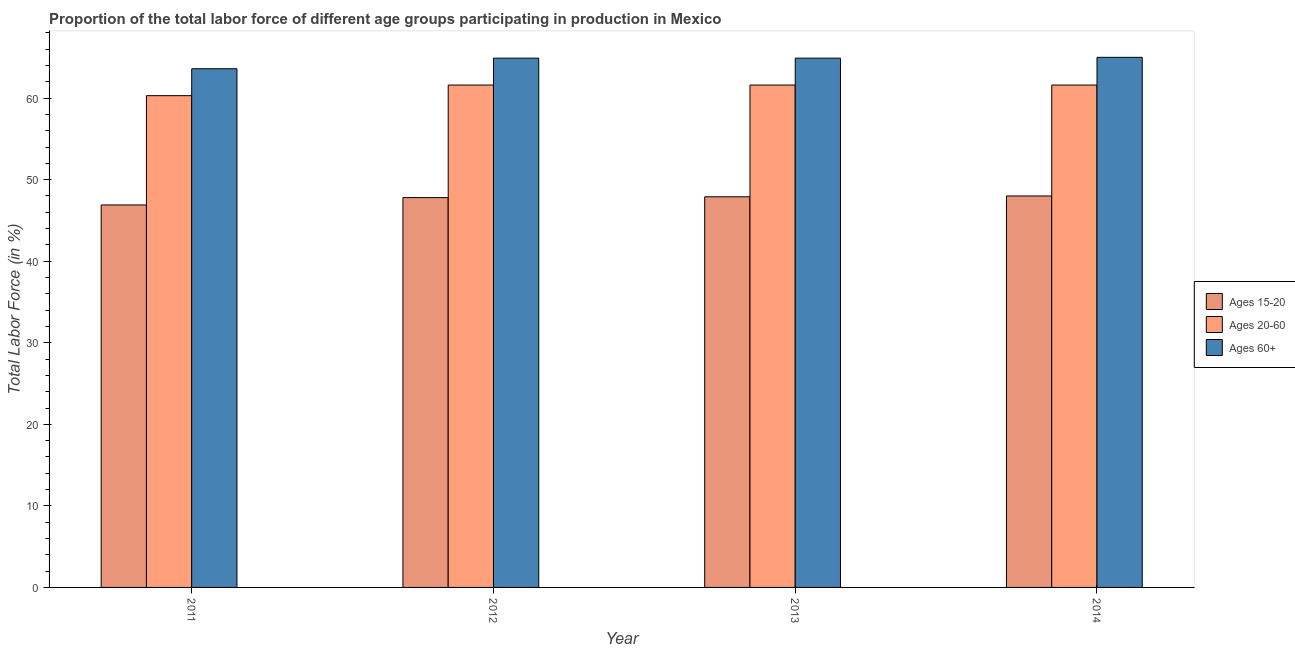Are the number of bars per tick equal to the number of legend labels?
Ensure brevity in your answer.  Yes. How many bars are there on the 4th tick from the left?
Make the answer very short. 3. How many bars are there on the 3rd tick from the right?
Ensure brevity in your answer.  3. What is the label of the 1st group of bars from the left?
Keep it short and to the point. 2011. In how many cases, is the number of bars for a given year not equal to the number of legend labels?
Provide a short and direct response. 0. What is the percentage of labor force within the age group 15-20 in 2011?
Provide a short and direct response. 46.9. Across all years, what is the maximum percentage of labor force above age 60?
Provide a short and direct response. 65. Across all years, what is the minimum percentage of labor force within the age group 20-60?
Your response must be concise. 60.3. What is the total percentage of labor force within the age group 15-20 in the graph?
Provide a short and direct response. 190.6. What is the difference between the percentage of labor force within the age group 15-20 in 2011 and that in 2012?
Your response must be concise. -0.9. What is the difference between the percentage of labor force within the age group 15-20 in 2013 and the percentage of labor force above age 60 in 2012?
Your answer should be compact. 0.1. What is the average percentage of labor force above age 60 per year?
Make the answer very short. 64.6. What is the ratio of the percentage of labor force within the age group 15-20 in 2013 to that in 2014?
Keep it short and to the point. 1. Is the percentage of labor force within the age group 15-20 in 2012 less than that in 2014?
Provide a succinct answer. Yes. What is the difference between the highest and the second highest percentage of labor force above age 60?
Offer a terse response. 0.1. What is the difference between the highest and the lowest percentage of labor force within the age group 20-60?
Keep it short and to the point. 1.3. In how many years, is the percentage of labor force within the age group 15-20 greater than the average percentage of labor force within the age group 15-20 taken over all years?
Provide a succinct answer. 3. What does the 2nd bar from the left in 2013 represents?
Give a very brief answer. Ages 20-60. What does the 2nd bar from the right in 2011 represents?
Ensure brevity in your answer.  Ages 20-60. Is it the case that in every year, the sum of the percentage of labor force within the age group 15-20 and percentage of labor force within the age group 20-60 is greater than the percentage of labor force above age 60?
Provide a succinct answer. Yes. How many bars are there?
Give a very brief answer. 12. What is the difference between two consecutive major ticks on the Y-axis?
Provide a short and direct response. 10. Are the values on the major ticks of Y-axis written in scientific E-notation?
Offer a terse response. No. What is the title of the graph?
Offer a very short reply. Proportion of the total labor force of different age groups participating in production in Mexico. Does "Infant(male)" appear as one of the legend labels in the graph?
Your answer should be compact. No. What is the label or title of the X-axis?
Keep it short and to the point. Year. What is the Total Labor Force (in %) of Ages 15-20 in 2011?
Offer a very short reply. 46.9. What is the Total Labor Force (in %) of Ages 20-60 in 2011?
Offer a very short reply. 60.3. What is the Total Labor Force (in %) of Ages 60+ in 2011?
Provide a succinct answer. 63.6. What is the Total Labor Force (in %) of Ages 15-20 in 2012?
Your answer should be compact. 47.8. What is the Total Labor Force (in %) of Ages 20-60 in 2012?
Keep it short and to the point. 61.6. What is the Total Labor Force (in %) in Ages 60+ in 2012?
Your answer should be very brief. 64.9. What is the Total Labor Force (in %) in Ages 15-20 in 2013?
Offer a very short reply. 47.9. What is the Total Labor Force (in %) in Ages 20-60 in 2013?
Provide a succinct answer. 61.6. What is the Total Labor Force (in %) in Ages 60+ in 2013?
Offer a very short reply. 64.9. What is the Total Labor Force (in %) in Ages 15-20 in 2014?
Give a very brief answer. 48. What is the Total Labor Force (in %) of Ages 20-60 in 2014?
Your answer should be compact. 61.6. Across all years, what is the maximum Total Labor Force (in %) of Ages 15-20?
Make the answer very short. 48. Across all years, what is the maximum Total Labor Force (in %) of Ages 20-60?
Provide a short and direct response. 61.6. Across all years, what is the minimum Total Labor Force (in %) of Ages 15-20?
Offer a very short reply. 46.9. Across all years, what is the minimum Total Labor Force (in %) of Ages 20-60?
Offer a terse response. 60.3. Across all years, what is the minimum Total Labor Force (in %) of Ages 60+?
Provide a succinct answer. 63.6. What is the total Total Labor Force (in %) of Ages 15-20 in the graph?
Make the answer very short. 190.6. What is the total Total Labor Force (in %) of Ages 20-60 in the graph?
Offer a very short reply. 245.1. What is the total Total Labor Force (in %) of Ages 60+ in the graph?
Provide a short and direct response. 258.4. What is the difference between the Total Labor Force (in %) in Ages 15-20 in 2011 and that in 2013?
Offer a very short reply. -1. What is the difference between the Total Labor Force (in %) of Ages 15-20 in 2011 and that in 2014?
Keep it short and to the point. -1.1. What is the difference between the Total Labor Force (in %) in Ages 60+ in 2011 and that in 2014?
Give a very brief answer. -1.4. What is the difference between the Total Labor Force (in %) of Ages 15-20 in 2012 and that in 2013?
Ensure brevity in your answer.  -0.1. What is the difference between the Total Labor Force (in %) in Ages 60+ in 2012 and that in 2013?
Provide a short and direct response. 0. What is the difference between the Total Labor Force (in %) of Ages 15-20 in 2012 and that in 2014?
Keep it short and to the point. -0.2. What is the difference between the Total Labor Force (in %) of Ages 60+ in 2013 and that in 2014?
Your answer should be very brief. -0.1. What is the difference between the Total Labor Force (in %) in Ages 15-20 in 2011 and the Total Labor Force (in %) in Ages 20-60 in 2012?
Provide a short and direct response. -14.7. What is the difference between the Total Labor Force (in %) of Ages 20-60 in 2011 and the Total Labor Force (in %) of Ages 60+ in 2012?
Provide a short and direct response. -4.6. What is the difference between the Total Labor Force (in %) in Ages 15-20 in 2011 and the Total Labor Force (in %) in Ages 20-60 in 2013?
Keep it short and to the point. -14.7. What is the difference between the Total Labor Force (in %) in Ages 20-60 in 2011 and the Total Labor Force (in %) in Ages 60+ in 2013?
Your response must be concise. -4.6. What is the difference between the Total Labor Force (in %) in Ages 15-20 in 2011 and the Total Labor Force (in %) in Ages 20-60 in 2014?
Offer a very short reply. -14.7. What is the difference between the Total Labor Force (in %) of Ages 15-20 in 2011 and the Total Labor Force (in %) of Ages 60+ in 2014?
Provide a succinct answer. -18.1. What is the difference between the Total Labor Force (in %) in Ages 20-60 in 2011 and the Total Labor Force (in %) in Ages 60+ in 2014?
Keep it short and to the point. -4.7. What is the difference between the Total Labor Force (in %) of Ages 15-20 in 2012 and the Total Labor Force (in %) of Ages 60+ in 2013?
Ensure brevity in your answer.  -17.1. What is the difference between the Total Labor Force (in %) in Ages 20-60 in 2012 and the Total Labor Force (in %) in Ages 60+ in 2013?
Offer a terse response. -3.3. What is the difference between the Total Labor Force (in %) in Ages 15-20 in 2012 and the Total Labor Force (in %) in Ages 60+ in 2014?
Your answer should be very brief. -17.2. What is the difference between the Total Labor Force (in %) of Ages 20-60 in 2012 and the Total Labor Force (in %) of Ages 60+ in 2014?
Ensure brevity in your answer.  -3.4. What is the difference between the Total Labor Force (in %) in Ages 15-20 in 2013 and the Total Labor Force (in %) in Ages 20-60 in 2014?
Offer a terse response. -13.7. What is the difference between the Total Labor Force (in %) of Ages 15-20 in 2013 and the Total Labor Force (in %) of Ages 60+ in 2014?
Your response must be concise. -17.1. What is the average Total Labor Force (in %) in Ages 15-20 per year?
Your answer should be very brief. 47.65. What is the average Total Labor Force (in %) of Ages 20-60 per year?
Your answer should be very brief. 61.27. What is the average Total Labor Force (in %) in Ages 60+ per year?
Provide a succinct answer. 64.6. In the year 2011, what is the difference between the Total Labor Force (in %) of Ages 15-20 and Total Labor Force (in %) of Ages 60+?
Your answer should be compact. -16.7. In the year 2012, what is the difference between the Total Labor Force (in %) in Ages 15-20 and Total Labor Force (in %) in Ages 60+?
Your answer should be compact. -17.1. In the year 2013, what is the difference between the Total Labor Force (in %) of Ages 15-20 and Total Labor Force (in %) of Ages 20-60?
Your response must be concise. -13.7. In the year 2013, what is the difference between the Total Labor Force (in %) of Ages 15-20 and Total Labor Force (in %) of Ages 60+?
Keep it short and to the point. -17. In the year 2014, what is the difference between the Total Labor Force (in %) in Ages 15-20 and Total Labor Force (in %) in Ages 20-60?
Your answer should be compact. -13.6. In the year 2014, what is the difference between the Total Labor Force (in %) of Ages 15-20 and Total Labor Force (in %) of Ages 60+?
Provide a succinct answer. -17. In the year 2014, what is the difference between the Total Labor Force (in %) of Ages 20-60 and Total Labor Force (in %) of Ages 60+?
Keep it short and to the point. -3.4. What is the ratio of the Total Labor Force (in %) in Ages 15-20 in 2011 to that in 2012?
Give a very brief answer. 0.98. What is the ratio of the Total Labor Force (in %) in Ages 20-60 in 2011 to that in 2012?
Ensure brevity in your answer.  0.98. What is the ratio of the Total Labor Force (in %) in Ages 15-20 in 2011 to that in 2013?
Provide a short and direct response. 0.98. What is the ratio of the Total Labor Force (in %) in Ages 20-60 in 2011 to that in 2013?
Keep it short and to the point. 0.98. What is the ratio of the Total Labor Force (in %) of Ages 15-20 in 2011 to that in 2014?
Make the answer very short. 0.98. What is the ratio of the Total Labor Force (in %) of Ages 20-60 in 2011 to that in 2014?
Provide a succinct answer. 0.98. What is the ratio of the Total Labor Force (in %) in Ages 60+ in 2011 to that in 2014?
Offer a very short reply. 0.98. What is the ratio of the Total Labor Force (in %) of Ages 15-20 in 2012 to that in 2013?
Give a very brief answer. 1. What is the ratio of the Total Labor Force (in %) in Ages 20-60 in 2012 to that in 2013?
Ensure brevity in your answer.  1. What is the ratio of the Total Labor Force (in %) of Ages 15-20 in 2012 to that in 2014?
Offer a terse response. 1. What is the ratio of the Total Labor Force (in %) of Ages 15-20 in 2013 to that in 2014?
Make the answer very short. 1. What is the ratio of the Total Labor Force (in %) of Ages 60+ in 2013 to that in 2014?
Offer a very short reply. 1. What is the difference between the highest and the second highest Total Labor Force (in %) in Ages 15-20?
Provide a short and direct response. 0.1. What is the difference between the highest and the second highest Total Labor Force (in %) of Ages 20-60?
Provide a succinct answer. 0. What is the difference between the highest and the second highest Total Labor Force (in %) of Ages 60+?
Ensure brevity in your answer.  0.1. What is the difference between the highest and the lowest Total Labor Force (in %) of Ages 15-20?
Offer a very short reply. 1.1. What is the difference between the highest and the lowest Total Labor Force (in %) of Ages 20-60?
Your answer should be compact. 1.3. 